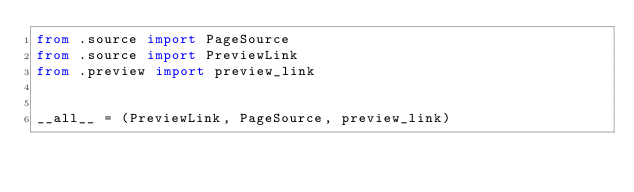Convert code to text. <code><loc_0><loc_0><loc_500><loc_500><_Python_>from .source import PageSource
from .source import PreviewLink
from .preview import preview_link


__all__ = (PreviewLink, PageSource, preview_link)
</code> 